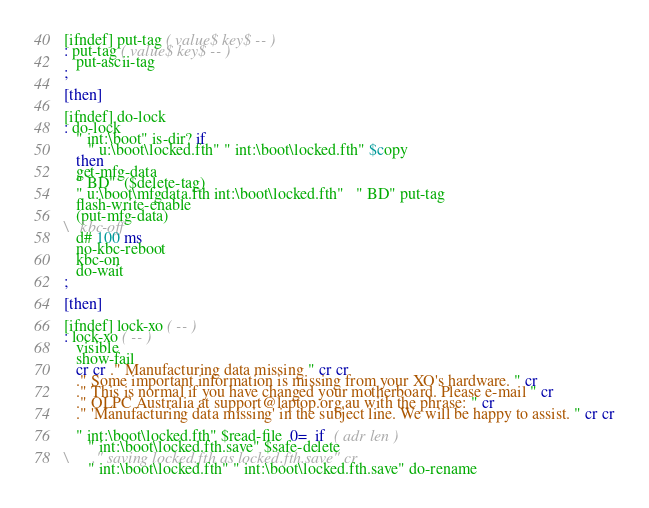<code> <loc_0><loc_0><loc_500><loc_500><_Forth_>
[ifndef] put-tag ( value$ key$ -- )
: put-tag ( value$ key$ -- )
   put-ascii-tag
;

[then]

[ifndef] do-lock
: do-lock
   " int:\boot" is-dir? if
      " u:\boot\locked.fth" " int:\boot\locked.fth" $copy 
   then
   get-mfg-data
   " BD"  ($delete-tag)
   " u:\boot\mfgdata.fth int:\boot\locked.fth"   " BD" put-tag
   flash-write-enable
   (put-mfg-data)
\   kbc-off
   d# 100 ms
   no-kbc-reboot
   kbc-on
   do-wait
;

[then]

[ifndef] lock-xo ( -- )
: lock-xo ( -- )
   visible
   show-fail
   cr cr ." Manufacturing data missing " cr cr
   ." Some important information is missing from your XO's hardware. " cr
   ." This is normal if you have changed your motherboard. Please e-mail " cr
   ." OLPC Australia at support@laptop.org.au with the phrase: " cr
   ." 'Manufacturing data missing' in the subject line. We will be happy to assist. " cr cr

   " int:\boot\locked.fth" $read-file  0=  if  ( adr len )
      " int:\boot\locked.fth.save" $safe-delete
\      ." saving locked.fth as locked.fth.save" cr
      " int:\boot\locked.fth" " int:\boot\locked.fth.save" do-rename</code> 